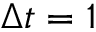<formula> <loc_0><loc_0><loc_500><loc_500>\Delta t = 1</formula> 